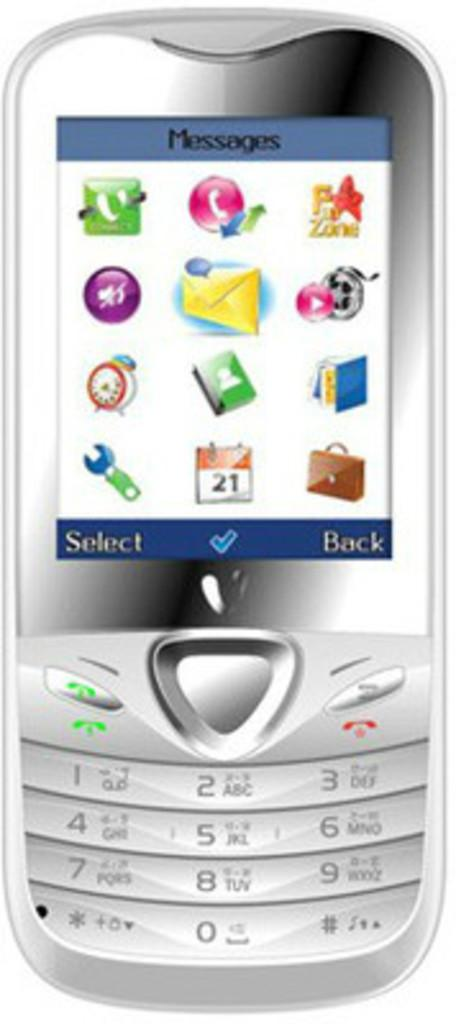<image>
Share a concise interpretation of the image provided. A silver cellphone with the top of the display screen saying Messages 